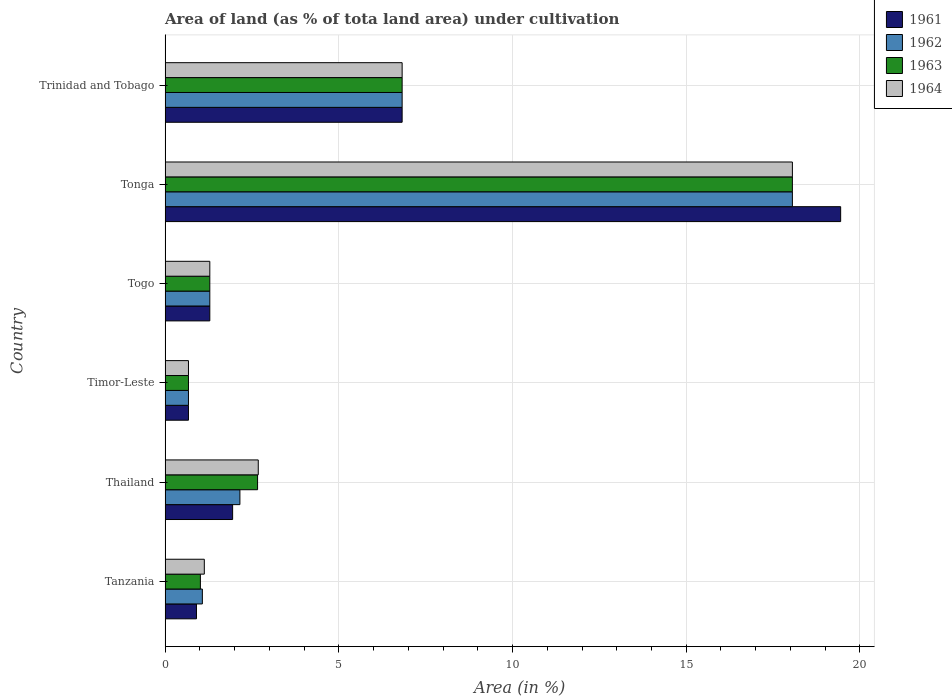How many different coloured bars are there?
Keep it short and to the point. 4. Are the number of bars per tick equal to the number of legend labels?
Ensure brevity in your answer.  Yes. How many bars are there on the 6th tick from the top?
Keep it short and to the point. 4. What is the label of the 3rd group of bars from the top?
Your answer should be very brief. Togo. What is the percentage of land under cultivation in 1961 in Togo?
Offer a terse response. 1.29. Across all countries, what is the maximum percentage of land under cultivation in 1964?
Give a very brief answer. 18.06. Across all countries, what is the minimum percentage of land under cultivation in 1963?
Your response must be concise. 0.67. In which country was the percentage of land under cultivation in 1964 maximum?
Provide a succinct answer. Tonga. In which country was the percentage of land under cultivation in 1964 minimum?
Your answer should be very brief. Timor-Leste. What is the total percentage of land under cultivation in 1961 in the graph?
Ensure brevity in your answer.  31.07. What is the difference between the percentage of land under cultivation in 1961 in Timor-Leste and that in Trinidad and Tobago?
Make the answer very short. -6.15. What is the difference between the percentage of land under cultivation in 1962 in Tanzania and the percentage of land under cultivation in 1961 in Trinidad and Tobago?
Give a very brief answer. -5.75. What is the average percentage of land under cultivation in 1964 per country?
Offer a very short reply. 5.11. What is the difference between the percentage of land under cultivation in 1962 and percentage of land under cultivation in 1963 in Togo?
Ensure brevity in your answer.  0. In how many countries, is the percentage of land under cultivation in 1962 greater than 14 %?
Give a very brief answer. 1. What is the ratio of the percentage of land under cultivation in 1961 in Timor-Leste to that in Trinidad and Tobago?
Your response must be concise. 0.1. Is the percentage of land under cultivation in 1964 in Timor-Leste less than that in Trinidad and Tobago?
Your answer should be very brief. Yes. Is the difference between the percentage of land under cultivation in 1962 in Tonga and Trinidad and Tobago greater than the difference between the percentage of land under cultivation in 1963 in Tonga and Trinidad and Tobago?
Offer a very short reply. No. What is the difference between the highest and the second highest percentage of land under cultivation in 1962?
Your answer should be compact. 11.23. What is the difference between the highest and the lowest percentage of land under cultivation in 1961?
Your answer should be compact. 18.77. In how many countries, is the percentage of land under cultivation in 1961 greater than the average percentage of land under cultivation in 1961 taken over all countries?
Make the answer very short. 2. Is the sum of the percentage of land under cultivation in 1962 in Togo and Tonga greater than the maximum percentage of land under cultivation in 1964 across all countries?
Make the answer very short. Yes. Is it the case that in every country, the sum of the percentage of land under cultivation in 1964 and percentage of land under cultivation in 1962 is greater than the sum of percentage of land under cultivation in 1963 and percentage of land under cultivation in 1961?
Make the answer very short. No. What does the 3rd bar from the top in Tonga represents?
Your answer should be compact. 1962. Is it the case that in every country, the sum of the percentage of land under cultivation in 1961 and percentage of land under cultivation in 1964 is greater than the percentage of land under cultivation in 1963?
Ensure brevity in your answer.  Yes. What is the difference between two consecutive major ticks on the X-axis?
Give a very brief answer. 5. Are the values on the major ticks of X-axis written in scientific E-notation?
Your response must be concise. No. Does the graph contain any zero values?
Keep it short and to the point. No. Does the graph contain grids?
Your response must be concise. Yes. Where does the legend appear in the graph?
Keep it short and to the point. Top right. How are the legend labels stacked?
Provide a short and direct response. Vertical. What is the title of the graph?
Provide a short and direct response. Area of land (as % of tota land area) under cultivation. Does "1976" appear as one of the legend labels in the graph?
Offer a very short reply. No. What is the label or title of the X-axis?
Ensure brevity in your answer.  Area (in %). What is the label or title of the Y-axis?
Your response must be concise. Country. What is the Area (in %) of 1961 in Tanzania?
Ensure brevity in your answer.  0.9. What is the Area (in %) of 1962 in Tanzania?
Ensure brevity in your answer.  1.07. What is the Area (in %) of 1963 in Tanzania?
Ensure brevity in your answer.  1.02. What is the Area (in %) of 1964 in Tanzania?
Make the answer very short. 1.13. What is the Area (in %) in 1961 in Thailand?
Your answer should be compact. 1.94. What is the Area (in %) in 1962 in Thailand?
Ensure brevity in your answer.  2.15. What is the Area (in %) of 1963 in Thailand?
Make the answer very short. 2.66. What is the Area (in %) of 1964 in Thailand?
Ensure brevity in your answer.  2.68. What is the Area (in %) in 1961 in Timor-Leste?
Your answer should be very brief. 0.67. What is the Area (in %) in 1962 in Timor-Leste?
Offer a very short reply. 0.67. What is the Area (in %) in 1963 in Timor-Leste?
Provide a succinct answer. 0.67. What is the Area (in %) of 1964 in Timor-Leste?
Keep it short and to the point. 0.67. What is the Area (in %) in 1961 in Togo?
Your answer should be compact. 1.29. What is the Area (in %) in 1962 in Togo?
Ensure brevity in your answer.  1.29. What is the Area (in %) in 1963 in Togo?
Your response must be concise. 1.29. What is the Area (in %) of 1964 in Togo?
Keep it short and to the point. 1.29. What is the Area (in %) in 1961 in Tonga?
Provide a short and direct response. 19.44. What is the Area (in %) of 1962 in Tonga?
Your answer should be very brief. 18.06. What is the Area (in %) of 1963 in Tonga?
Your response must be concise. 18.06. What is the Area (in %) of 1964 in Tonga?
Your answer should be very brief. 18.06. What is the Area (in %) of 1961 in Trinidad and Tobago?
Give a very brief answer. 6.82. What is the Area (in %) in 1962 in Trinidad and Tobago?
Offer a terse response. 6.82. What is the Area (in %) in 1963 in Trinidad and Tobago?
Provide a succinct answer. 6.82. What is the Area (in %) in 1964 in Trinidad and Tobago?
Your answer should be compact. 6.82. Across all countries, what is the maximum Area (in %) of 1961?
Provide a succinct answer. 19.44. Across all countries, what is the maximum Area (in %) in 1962?
Give a very brief answer. 18.06. Across all countries, what is the maximum Area (in %) of 1963?
Give a very brief answer. 18.06. Across all countries, what is the maximum Area (in %) in 1964?
Keep it short and to the point. 18.06. Across all countries, what is the minimum Area (in %) in 1961?
Keep it short and to the point. 0.67. Across all countries, what is the minimum Area (in %) in 1962?
Provide a short and direct response. 0.67. Across all countries, what is the minimum Area (in %) of 1963?
Your answer should be compact. 0.67. Across all countries, what is the minimum Area (in %) of 1964?
Your answer should be very brief. 0.67. What is the total Area (in %) in 1961 in the graph?
Keep it short and to the point. 31.07. What is the total Area (in %) in 1962 in the graph?
Provide a short and direct response. 30.06. What is the total Area (in %) in 1963 in the graph?
Keep it short and to the point. 30.52. What is the total Area (in %) of 1964 in the graph?
Keep it short and to the point. 30.65. What is the difference between the Area (in %) in 1961 in Tanzania and that in Thailand?
Make the answer very short. -1.04. What is the difference between the Area (in %) in 1962 in Tanzania and that in Thailand?
Offer a very short reply. -1.08. What is the difference between the Area (in %) in 1963 in Tanzania and that in Thailand?
Provide a short and direct response. -1.65. What is the difference between the Area (in %) of 1964 in Tanzania and that in Thailand?
Your answer should be very brief. -1.55. What is the difference between the Area (in %) in 1961 in Tanzania and that in Timor-Leste?
Offer a very short reply. 0.23. What is the difference between the Area (in %) in 1962 in Tanzania and that in Timor-Leste?
Your response must be concise. 0.4. What is the difference between the Area (in %) of 1963 in Tanzania and that in Timor-Leste?
Your answer should be very brief. 0.34. What is the difference between the Area (in %) in 1964 in Tanzania and that in Timor-Leste?
Provide a short and direct response. 0.46. What is the difference between the Area (in %) of 1961 in Tanzania and that in Togo?
Your response must be concise. -0.38. What is the difference between the Area (in %) of 1962 in Tanzania and that in Togo?
Provide a short and direct response. -0.21. What is the difference between the Area (in %) of 1963 in Tanzania and that in Togo?
Your answer should be compact. -0.27. What is the difference between the Area (in %) of 1964 in Tanzania and that in Togo?
Your response must be concise. -0.16. What is the difference between the Area (in %) of 1961 in Tanzania and that in Tonga?
Ensure brevity in your answer.  -18.54. What is the difference between the Area (in %) in 1962 in Tanzania and that in Tonga?
Offer a terse response. -16.98. What is the difference between the Area (in %) of 1963 in Tanzania and that in Tonga?
Offer a terse response. -17.04. What is the difference between the Area (in %) in 1964 in Tanzania and that in Tonga?
Give a very brief answer. -16.93. What is the difference between the Area (in %) of 1961 in Tanzania and that in Trinidad and Tobago?
Your answer should be very brief. -5.92. What is the difference between the Area (in %) in 1962 in Tanzania and that in Trinidad and Tobago?
Your answer should be compact. -5.75. What is the difference between the Area (in %) in 1963 in Tanzania and that in Trinidad and Tobago?
Make the answer very short. -5.81. What is the difference between the Area (in %) in 1964 in Tanzania and that in Trinidad and Tobago?
Make the answer very short. -5.69. What is the difference between the Area (in %) of 1961 in Thailand and that in Timor-Leste?
Give a very brief answer. 1.27. What is the difference between the Area (in %) of 1962 in Thailand and that in Timor-Leste?
Your answer should be compact. 1.48. What is the difference between the Area (in %) of 1963 in Thailand and that in Timor-Leste?
Offer a very short reply. 1.99. What is the difference between the Area (in %) in 1964 in Thailand and that in Timor-Leste?
Provide a short and direct response. 2.01. What is the difference between the Area (in %) of 1961 in Thailand and that in Togo?
Keep it short and to the point. 0.66. What is the difference between the Area (in %) of 1962 in Thailand and that in Togo?
Ensure brevity in your answer.  0.87. What is the difference between the Area (in %) in 1963 in Thailand and that in Togo?
Offer a terse response. 1.38. What is the difference between the Area (in %) in 1964 in Thailand and that in Togo?
Offer a terse response. 1.39. What is the difference between the Area (in %) in 1961 in Thailand and that in Tonga?
Provide a short and direct response. -17.5. What is the difference between the Area (in %) in 1962 in Thailand and that in Tonga?
Offer a terse response. -15.9. What is the difference between the Area (in %) of 1963 in Thailand and that in Tonga?
Your answer should be very brief. -15.39. What is the difference between the Area (in %) in 1964 in Thailand and that in Tonga?
Make the answer very short. -15.37. What is the difference between the Area (in %) of 1961 in Thailand and that in Trinidad and Tobago?
Your answer should be compact. -4.88. What is the difference between the Area (in %) of 1962 in Thailand and that in Trinidad and Tobago?
Offer a very short reply. -4.67. What is the difference between the Area (in %) of 1963 in Thailand and that in Trinidad and Tobago?
Keep it short and to the point. -4.16. What is the difference between the Area (in %) of 1964 in Thailand and that in Trinidad and Tobago?
Your response must be concise. -4.14. What is the difference between the Area (in %) in 1961 in Timor-Leste and that in Togo?
Your answer should be very brief. -0.61. What is the difference between the Area (in %) in 1962 in Timor-Leste and that in Togo?
Provide a succinct answer. -0.61. What is the difference between the Area (in %) of 1963 in Timor-Leste and that in Togo?
Offer a very short reply. -0.61. What is the difference between the Area (in %) of 1964 in Timor-Leste and that in Togo?
Make the answer very short. -0.61. What is the difference between the Area (in %) in 1961 in Timor-Leste and that in Tonga?
Make the answer very short. -18.77. What is the difference between the Area (in %) of 1962 in Timor-Leste and that in Tonga?
Offer a very short reply. -17.38. What is the difference between the Area (in %) in 1963 in Timor-Leste and that in Tonga?
Provide a short and direct response. -17.38. What is the difference between the Area (in %) in 1964 in Timor-Leste and that in Tonga?
Make the answer very short. -17.38. What is the difference between the Area (in %) in 1961 in Timor-Leste and that in Trinidad and Tobago?
Provide a succinct answer. -6.15. What is the difference between the Area (in %) of 1962 in Timor-Leste and that in Trinidad and Tobago?
Make the answer very short. -6.15. What is the difference between the Area (in %) of 1963 in Timor-Leste and that in Trinidad and Tobago?
Your answer should be compact. -6.15. What is the difference between the Area (in %) of 1964 in Timor-Leste and that in Trinidad and Tobago?
Your response must be concise. -6.15. What is the difference between the Area (in %) of 1961 in Togo and that in Tonga?
Ensure brevity in your answer.  -18.16. What is the difference between the Area (in %) in 1962 in Togo and that in Tonga?
Your answer should be very brief. -16.77. What is the difference between the Area (in %) in 1963 in Togo and that in Tonga?
Keep it short and to the point. -16.77. What is the difference between the Area (in %) of 1964 in Togo and that in Tonga?
Provide a short and direct response. -16.77. What is the difference between the Area (in %) in 1961 in Togo and that in Trinidad and Tobago?
Ensure brevity in your answer.  -5.54. What is the difference between the Area (in %) in 1962 in Togo and that in Trinidad and Tobago?
Your answer should be very brief. -5.54. What is the difference between the Area (in %) in 1963 in Togo and that in Trinidad and Tobago?
Give a very brief answer. -5.54. What is the difference between the Area (in %) in 1964 in Togo and that in Trinidad and Tobago?
Your answer should be very brief. -5.54. What is the difference between the Area (in %) of 1961 in Tonga and that in Trinidad and Tobago?
Make the answer very short. 12.62. What is the difference between the Area (in %) of 1962 in Tonga and that in Trinidad and Tobago?
Give a very brief answer. 11.23. What is the difference between the Area (in %) in 1963 in Tonga and that in Trinidad and Tobago?
Ensure brevity in your answer.  11.23. What is the difference between the Area (in %) in 1964 in Tonga and that in Trinidad and Tobago?
Your answer should be compact. 11.23. What is the difference between the Area (in %) of 1961 in Tanzania and the Area (in %) of 1962 in Thailand?
Your response must be concise. -1.25. What is the difference between the Area (in %) of 1961 in Tanzania and the Area (in %) of 1963 in Thailand?
Offer a terse response. -1.76. What is the difference between the Area (in %) in 1961 in Tanzania and the Area (in %) in 1964 in Thailand?
Offer a very short reply. -1.78. What is the difference between the Area (in %) in 1962 in Tanzania and the Area (in %) in 1963 in Thailand?
Offer a very short reply. -1.59. What is the difference between the Area (in %) of 1962 in Tanzania and the Area (in %) of 1964 in Thailand?
Make the answer very short. -1.61. What is the difference between the Area (in %) of 1963 in Tanzania and the Area (in %) of 1964 in Thailand?
Provide a short and direct response. -1.67. What is the difference between the Area (in %) of 1961 in Tanzania and the Area (in %) of 1962 in Timor-Leste?
Offer a very short reply. 0.23. What is the difference between the Area (in %) in 1961 in Tanzania and the Area (in %) in 1963 in Timor-Leste?
Your answer should be compact. 0.23. What is the difference between the Area (in %) in 1961 in Tanzania and the Area (in %) in 1964 in Timor-Leste?
Provide a succinct answer. 0.23. What is the difference between the Area (in %) of 1962 in Tanzania and the Area (in %) of 1963 in Timor-Leste?
Offer a terse response. 0.4. What is the difference between the Area (in %) of 1962 in Tanzania and the Area (in %) of 1964 in Timor-Leste?
Offer a very short reply. 0.4. What is the difference between the Area (in %) of 1963 in Tanzania and the Area (in %) of 1964 in Timor-Leste?
Offer a terse response. 0.34. What is the difference between the Area (in %) of 1961 in Tanzania and the Area (in %) of 1962 in Togo?
Make the answer very short. -0.38. What is the difference between the Area (in %) in 1961 in Tanzania and the Area (in %) in 1963 in Togo?
Provide a succinct answer. -0.38. What is the difference between the Area (in %) of 1961 in Tanzania and the Area (in %) of 1964 in Togo?
Your answer should be compact. -0.38. What is the difference between the Area (in %) of 1962 in Tanzania and the Area (in %) of 1963 in Togo?
Your answer should be compact. -0.21. What is the difference between the Area (in %) of 1962 in Tanzania and the Area (in %) of 1964 in Togo?
Make the answer very short. -0.21. What is the difference between the Area (in %) of 1963 in Tanzania and the Area (in %) of 1964 in Togo?
Offer a very short reply. -0.27. What is the difference between the Area (in %) of 1961 in Tanzania and the Area (in %) of 1962 in Tonga?
Offer a terse response. -17.15. What is the difference between the Area (in %) of 1961 in Tanzania and the Area (in %) of 1963 in Tonga?
Provide a short and direct response. -17.15. What is the difference between the Area (in %) of 1961 in Tanzania and the Area (in %) of 1964 in Tonga?
Your response must be concise. -17.15. What is the difference between the Area (in %) in 1962 in Tanzania and the Area (in %) in 1963 in Tonga?
Provide a succinct answer. -16.98. What is the difference between the Area (in %) of 1962 in Tanzania and the Area (in %) of 1964 in Tonga?
Your response must be concise. -16.98. What is the difference between the Area (in %) in 1963 in Tanzania and the Area (in %) in 1964 in Tonga?
Make the answer very short. -17.04. What is the difference between the Area (in %) of 1961 in Tanzania and the Area (in %) of 1962 in Trinidad and Tobago?
Your response must be concise. -5.92. What is the difference between the Area (in %) of 1961 in Tanzania and the Area (in %) of 1963 in Trinidad and Tobago?
Ensure brevity in your answer.  -5.92. What is the difference between the Area (in %) in 1961 in Tanzania and the Area (in %) in 1964 in Trinidad and Tobago?
Your response must be concise. -5.92. What is the difference between the Area (in %) of 1962 in Tanzania and the Area (in %) of 1963 in Trinidad and Tobago?
Ensure brevity in your answer.  -5.75. What is the difference between the Area (in %) in 1962 in Tanzania and the Area (in %) in 1964 in Trinidad and Tobago?
Ensure brevity in your answer.  -5.75. What is the difference between the Area (in %) of 1963 in Tanzania and the Area (in %) of 1964 in Trinidad and Tobago?
Ensure brevity in your answer.  -5.81. What is the difference between the Area (in %) in 1961 in Thailand and the Area (in %) in 1962 in Timor-Leste?
Ensure brevity in your answer.  1.27. What is the difference between the Area (in %) in 1961 in Thailand and the Area (in %) in 1963 in Timor-Leste?
Your response must be concise. 1.27. What is the difference between the Area (in %) of 1961 in Thailand and the Area (in %) of 1964 in Timor-Leste?
Offer a terse response. 1.27. What is the difference between the Area (in %) of 1962 in Thailand and the Area (in %) of 1963 in Timor-Leste?
Your answer should be very brief. 1.48. What is the difference between the Area (in %) in 1962 in Thailand and the Area (in %) in 1964 in Timor-Leste?
Offer a very short reply. 1.48. What is the difference between the Area (in %) in 1963 in Thailand and the Area (in %) in 1964 in Timor-Leste?
Your answer should be compact. 1.99. What is the difference between the Area (in %) in 1961 in Thailand and the Area (in %) in 1962 in Togo?
Offer a very short reply. 0.66. What is the difference between the Area (in %) of 1961 in Thailand and the Area (in %) of 1963 in Togo?
Offer a very short reply. 0.66. What is the difference between the Area (in %) of 1961 in Thailand and the Area (in %) of 1964 in Togo?
Your answer should be compact. 0.66. What is the difference between the Area (in %) in 1962 in Thailand and the Area (in %) in 1963 in Togo?
Give a very brief answer. 0.87. What is the difference between the Area (in %) in 1962 in Thailand and the Area (in %) in 1964 in Togo?
Your response must be concise. 0.87. What is the difference between the Area (in %) in 1963 in Thailand and the Area (in %) in 1964 in Togo?
Your answer should be compact. 1.38. What is the difference between the Area (in %) in 1961 in Thailand and the Area (in %) in 1962 in Tonga?
Offer a terse response. -16.11. What is the difference between the Area (in %) in 1961 in Thailand and the Area (in %) in 1963 in Tonga?
Your answer should be compact. -16.11. What is the difference between the Area (in %) of 1961 in Thailand and the Area (in %) of 1964 in Tonga?
Offer a very short reply. -16.11. What is the difference between the Area (in %) in 1962 in Thailand and the Area (in %) in 1963 in Tonga?
Keep it short and to the point. -15.9. What is the difference between the Area (in %) of 1962 in Thailand and the Area (in %) of 1964 in Tonga?
Provide a short and direct response. -15.9. What is the difference between the Area (in %) in 1963 in Thailand and the Area (in %) in 1964 in Tonga?
Your response must be concise. -15.39. What is the difference between the Area (in %) in 1961 in Thailand and the Area (in %) in 1962 in Trinidad and Tobago?
Keep it short and to the point. -4.88. What is the difference between the Area (in %) in 1961 in Thailand and the Area (in %) in 1963 in Trinidad and Tobago?
Make the answer very short. -4.88. What is the difference between the Area (in %) in 1961 in Thailand and the Area (in %) in 1964 in Trinidad and Tobago?
Keep it short and to the point. -4.88. What is the difference between the Area (in %) of 1962 in Thailand and the Area (in %) of 1963 in Trinidad and Tobago?
Your response must be concise. -4.67. What is the difference between the Area (in %) in 1962 in Thailand and the Area (in %) in 1964 in Trinidad and Tobago?
Make the answer very short. -4.67. What is the difference between the Area (in %) of 1963 in Thailand and the Area (in %) of 1964 in Trinidad and Tobago?
Your response must be concise. -4.16. What is the difference between the Area (in %) of 1961 in Timor-Leste and the Area (in %) of 1962 in Togo?
Give a very brief answer. -0.61. What is the difference between the Area (in %) of 1961 in Timor-Leste and the Area (in %) of 1963 in Togo?
Provide a succinct answer. -0.61. What is the difference between the Area (in %) of 1961 in Timor-Leste and the Area (in %) of 1964 in Togo?
Your answer should be very brief. -0.61. What is the difference between the Area (in %) in 1962 in Timor-Leste and the Area (in %) in 1963 in Togo?
Provide a short and direct response. -0.61. What is the difference between the Area (in %) of 1962 in Timor-Leste and the Area (in %) of 1964 in Togo?
Your response must be concise. -0.61. What is the difference between the Area (in %) in 1963 in Timor-Leste and the Area (in %) in 1964 in Togo?
Offer a very short reply. -0.61. What is the difference between the Area (in %) of 1961 in Timor-Leste and the Area (in %) of 1962 in Tonga?
Ensure brevity in your answer.  -17.38. What is the difference between the Area (in %) in 1961 in Timor-Leste and the Area (in %) in 1963 in Tonga?
Make the answer very short. -17.38. What is the difference between the Area (in %) in 1961 in Timor-Leste and the Area (in %) in 1964 in Tonga?
Provide a short and direct response. -17.38. What is the difference between the Area (in %) in 1962 in Timor-Leste and the Area (in %) in 1963 in Tonga?
Offer a terse response. -17.38. What is the difference between the Area (in %) in 1962 in Timor-Leste and the Area (in %) in 1964 in Tonga?
Offer a very short reply. -17.38. What is the difference between the Area (in %) in 1963 in Timor-Leste and the Area (in %) in 1964 in Tonga?
Provide a short and direct response. -17.38. What is the difference between the Area (in %) in 1961 in Timor-Leste and the Area (in %) in 1962 in Trinidad and Tobago?
Provide a succinct answer. -6.15. What is the difference between the Area (in %) of 1961 in Timor-Leste and the Area (in %) of 1963 in Trinidad and Tobago?
Provide a short and direct response. -6.15. What is the difference between the Area (in %) in 1961 in Timor-Leste and the Area (in %) in 1964 in Trinidad and Tobago?
Give a very brief answer. -6.15. What is the difference between the Area (in %) of 1962 in Timor-Leste and the Area (in %) of 1963 in Trinidad and Tobago?
Offer a terse response. -6.15. What is the difference between the Area (in %) of 1962 in Timor-Leste and the Area (in %) of 1964 in Trinidad and Tobago?
Provide a short and direct response. -6.15. What is the difference between the Area (in %) in 1963 in Timor-Leste and the Area (in %) in 1964 in Trinidad and Tobago?
Provide a short and direct response. -6.15. What is the difference between the Area (in %) in 1961 in Togo and the Area (in %) in 1962 in Tonga?
Your answer should be compact. -16.77. What is the difference between the Area (in %) in 1961 in Togo and the Area (in %) in 1963 in Tonga?
Your answer should be very brief. -16.77. What is the difference between the Area (in %) in 1961 in Togo and the Area (in %) in 1964 in Tonga?
Your answer should be compact. -16.77. What is the difference between the Area (in %) in 1962 in Togo and the Area (in %) in 1963 in Tonga?
Ensure brevity in your answer.  -16.77. What is the difference between the Area (in %) of 1962 in Togo and the Area (in %) of 1964 in Tonga?
Offer a terse response. -16.77. What is the difference between the Area (in %) of 1963 in Togo and the Area (in %) of 1964 in Tonga?
Ensure brevity in your answer.  -16.77. What is the difference between the Area (in %) of 1961 in Togo and the Area (in %) of 1962 in Trinidad and Tobago?
Give a very brief answer. -5.54. What is the difference between the Area (in %) in 1961 in Togo and the Area (in %) in 1963 in Trinidad and Tobago?
Offer a very short reply. -5.54. What is the difference between the Area (in %) in 1961 in Togo and the Area (in %) in 1964 in Trinidad and Tobago?
Provide a short and direct response. -5.54. What is the difference between the Area (in %) in 1962 in Togo and the Area (in %) in 1963 in Trinidad and Tobago?
Ensure brevity in your answer.  -5.54. What is the difference between the Area (in %) of 1962 in Togo and the Area (in %) of 1964 in Trinidad and Tobago?
Provide a short and direct response. -5.54. What is the difference between the Area (in %) of 1963 in Togo and the Area (in %) of 1964 in Trinidad and Tobago?
Offer a terse response. -5.54. What is the difference between the Area (in %) of 1961 in Tonga and the Area (in %) of 1962 in Trinidad and Tobago?
Your answer should be very brief. 12.62. What is the difference between the Area (in %) in 1961 in Tonga and the Area (in %) in 1963 in Trinidad and Tobago?
Your answer should be compact. 12.62. What is the difference between the Area (in %) in 1961 in Tonga and the Area (in %) in 1964 in Trinidad and Tobago?
Your response must be concise. 12.62. What is the difference between the Area (in %) in 1962 in Tonga and the Area (in %) in 1963 in Trinidad and Tobago?
Your answer should be compact. 11.23. What is the difference between the Area (in %) in 1962 in Tonga and the Area (in %) in 1964 in Trinidad and Tobago?
Offer a very short reply. 11.23. What is the difference between the Area (in %) in 1963 in Tonga and the Area (in %) in 1964 in Trinidad and Tobago?
Your answer should be compact. 11.23. What is the average Area (in %) of 1961 per country?
Give a very brief answer. 5.18. What is the average Area (in %) of 1962 per country?
Your response must be concise. 5.01. What is the average Area (in %) in 1963 per country?
Keep it short and to the point. 5.09. What is the average Area (in %) of 1964 per country?
Offer a very short reply. 5.11. What is the difference between the Area (in %) of 1961 and Area (in %) of 1962 in Tanzania?
Keep it short and to the point. -0.17. What is the difference between the Area (in %) in 1961 and Area (in %) in 1963 in Tanzania?
Keep it short and to the point. -0.11. What is the difference between the Area (in %) in 1961 and Area (in %) in 1964 in Tanzania?
Provide a short and direct response. -0.23. What is the difference between the Area (in %) in 1962 and Area (in %) in 1963 in Tanzania?
Offer a very short reply. 0.06. What is the difference between the Area (in %) of 1962 and Area (in %) of 1964 in Tanzania?
Make the answer very short. -0.06. What is the difference between the Area (in %) in 1963 and Area (in %) in 1964 in Tanzania?
Offer a terse response. -0.11. What is the difference between the Area (in %) in 1961 and Area (in %) in 1962 in Thailand?
Your answer should be very brief. -0.21. What is the difference between the Area (in %) of 1961 and Area (in %) of 1963 in Thailand?
Your answer should be compact. -0.72. What is the difference between the Area (in %) of 1961 and Area (in %) of 1964 in Thailand?
Provide a succinct answer. -0.74. What is the difference between the Area (in %) of 1962 and Area (in %) of 1963 in Thailand?
Your response must be concise. -0.51. What is the difference between the Area (in %) of 1962 and Area (in %) of 1964 in Thailand?
Your response must be concise. -0.53. What is the difference between the Area (in %) of 1963 and Area (in %) of 1964 in Thailand?
Keep it short and to the point. -0.02. What is the difference between the Area (in %) of 1961 and Area (in %) of 1962 in Timor-Leste?
Offer a terse response. 0. What is the difference between the Area (in %) in 1962 and Area (in %) in 1963 in Timor-Leste?
Provide a short and direct response. 0. What is the difference between the Area (in %) of 1962 and Area (in %) of 1964 in Timor-Leste?
Provide a short and direct response. 0. What is the difference between the Area (in %) of 1961 and Area (in %) of 1962 in Togo?
Your answer should be very brief. 0. What is the difference between the Area (in %) in 1961 and Area (in %) in 1964 in Togo?
Give a very brief answer. 0. What is the difference between the Area (in %) of 1961 and Area (in %) of 1962 in Tonga?
Make the answer very short. 1.39. What is the difference between the Area (in %) of 1961 and Area (in %) of 1963 in Tonga?
Offer a very short reply. 1.39. What is the difference between the Area (in %) in 1961 and Area (in %) in 1964 in Tonga?
Your answer should be compact. 1.39. What is the difference between the Area (in %) in 1962 and Area (in %) in 1964 in Tonga?
Your response must be concise. 0. What is the difference between the Area (in %) of 1963 and Area (in %) of 1964 in Tonga?
Give a very brief answer. 0. What is the difference between the Area (in %) in 1961 and Area (in %) in 1962 in Trinidad and Tobago?
Make the answer very short. 0. What is the difference between the Area (in %) of 1962 and Area (in %) of 1963 in Trinidad and Tobago?
Give a very brief answer. 0. What is the ratio of the Area (in %) of 1961 in Tanzania to that in Thailand?
Give a very brief answer. 0.46. What is the ratio of the Area (in %) of 1962 in Tanzania to that in Thailand?
Offer a terse response. 0.5. What is the ratio of the Area (in %) in 1963 in Tanzania to that in Thailand?
Provide a succinct answer. 0.38. What is the ratio of the Area (in %) in 1964 in Tanzania to that in Thailand?
Offer a terse response. 0.42. What is the ratio of the Area (in %) of 1961 in Tanzania to that in Timor-Leste?
Keep it short and to the point. 1.34. What is the ratio of the Area (in %) of 1962 in Tanzania to that in Timor-Leste?
Give a very brief answer. 1.59. What is the ratio of the Area (in %) of 1963 in Tanzania to that in Timor-Leste?
Your response must be concise. 1.51. What is the ratio of the Area (in %) of 1964 in Tanzania to that in Timor-Leste?
Offer a terse response. 1.68. What is the ratio of the Area (in %) of 1961 in Tanzania to that in Togo?
Your answer should be compact. 0.7. What is the ratio of the Area (in %) in 1963 in Tanzania to that in Togo?
Make the answer very short. 0.79. What is the ratio of the Area (in %) in 1964 in Tanzania to that in Togo?
Provide a short and direct response. 0.88. What is the ratio of the Area (in %) in 1961 in Tanzania to that in Tonga?
Provide a succinct answer. 0.05. What is the ratio of the Area (in %) of 1962 in Tanzania to that in Tonga?
Keep it short and to the point. 0.06. What is the ratio of the Area (in %) in 1963 in Tanzania to that in Tonga?
Make the answer very short. 0.06. What is the ratio of the Area (in %) in 1964 in Tanzania to that in Tonga?
Make the answer very short. 0.06. What is the ratio of the Area (in %) in 1961 in Tanzania to that in Trinidad and Tobago?
Your response must be concise. 0.13. What is the ratio of the Area (in %) of 1962 in Tanzania to that in Trinidad and Tobago?
Make the answer very short. 0.16. What is the ratio of the Area (in %) in 1963 in Tanzania to that in Trinidad and Tobago?
Offer a very short reply. 0.15. What is the ratio of the Area (in %) of 1964 in Tanzania to that in Trinidad and Tobago?
Make the answer very short. 0.17. What is the ratio of the Area (in %) in 1961 in Thailand to that in Timor-Leste?
Your answer should be very brief. 2.89. What is the ratio of the Area (in %) in 1962 in Thailand to that in Timor-Leste?
Give a very brief answer. 3.2. What is the ratio of the Area (in %) in 1963 in Thailand to that in Timor-Leste?
Make the answer very short. 3.96. What is the ratio of the Area (in %) in 1964 in Thailand to that in Timor-Leste?
Your answer should be compact. 3.99. What is the ratio of the Area (in %) of 1961 in Thailand to that in Togo?
Offer a terse response. 1.51. What is the ratio of the Area (in %) in 1962 in Thailand to that in Togo?
Your answer should be compact. 1.67. What is the ratio of the Area (in %) of 1963 in Thailand to that in Togo?
Your answer should be compact. 2.07. What is the ratio of the Area (in %) of 1964 in Thailand to that in Togo?
Keep it short and to the point. 2.08. What is the ratio of the Area (in %) in 1961 in Thailand to that in Tonga?
Provide a short and direct response. 0.1. What is the ratio of the Area (in %) of 1962 in Thailand to that in Tonga?
Make the answer very short. 0.12. What is the ratio of the Area (in %) in 1963 in Thailand to that in Tonga?
Provide a succinct answer. 0.15. What is the ratio of the Area (in %) in 1964 in Thailand to that in Tonga?
Give a very brief answer. 0.15. What is the ratio of the Area (in %) in 1961 in Thailand to that in Trinidad and Tobago?
Offer a very short reply. 0.28. What is the ratio of the Area (in %) in 1962 in Thailand to that in Trinidad and Tobago?
Give a very brief answer. 0.32. What is the ratio of the Area (in %) of 1963 in Thailand to that in Trinidad and Tobago?
Your answer should be very brief. 0.39. What is the ratio of the Area (in %) in 1964 in Thailand to that in Trinidad and Tobago?
Give a very brief answer. 0.39. What is the ratio of the Area (in %) in 1961 in Timor-Leste to that in Togo?
Provide a short and direct response. 0.52. What is the ratio of the Area (in %) in 1962 in Timor-Leste to that in Togo?
Your answer should be very brief. 0.52. What is the ratio of the Area (in %) of 1963 in Timor-Leste to that in Togo?
Make the answer very short. 0.52. What is the ratio of the Area (in %) of 1964 in Timor-Leste to that in Togo?
Provide a succinct answer. 0.52. What is the ratio of the Area (in %) in 1961 in Timor-Leste to that in Tonga?
Make the answer very short. 0.03. What is the ratio of the Area (in %) in 1962 in Timor-Leste to that in Tonga?
Keep it short and to the point. 0.04. What is the ratio of the Area (in %) of 1963 in Timor-Leste to that in Tonga?
Offer a very short reply. 0.04. What is the ratio of the Area (in %) of 1964 in Timor-Leste to that in Tonga?
Make the answer very short. 0.04. What is the ratio of the Area (in %) in 1961 in Timor-Leste to that in Trinidad and Tobago?
Offer a very short reply. 0.1. What is the ratio of the Area (in %) in 1962 in Timor-Leste to that in Trinidad and Tobago?
Offer a very short reply. 0.1. What is the ratio of the Area (in %) of 1963 in Timor-Leste to that in Trinidad and Tobago?
Keep it short and to the point. 0.1. What is the ratio of the Area (in %) of 1964 in Timor-Leste to that in Trinidad and Tobago?
Provide a short and direct response. 0.1. What is the ratio of the Area (in %) in 1961 in Togo to that in Tonga?
Offer a terse response. 0.07. What is the ratio of the Area (in %) of 1962 in Togo to that in Tonga?
Provide a short and direct response. 0.07. What is the ratio of the Area (in %) in 1963 in Togo to that in Tonga?
Provide a short and direct response. 0.07. What is the ratio of the Area (in %) in 1964 in Togo to that in Tonga?
Provide a succinct answer. 0.07. What is the ratio of the Area (in %) of 1961 in Togo to that in Trinidad and Tobago?
Your response must be concise. 0.19. What is the ratio of the Area (in %) in 1962 in Togo to that in Trinidad and Tobago?
Your response must be concise. 0.19. What is the ratio of the Area (in %) of 1963 in Togo to that in Trinidad and Tobago?
Keep it short and to the point. 0.19. What is the ratio of the Area (in %) of 1964 in Togo to that in Trinidad and Tobago?
Make the answer very short. 0.19. What is the ratio of the Area (in %) in 1961 in Tonga to that in Trinidad and Tobago?
Make the answer very short. 2.85. What is the ratio of the Area (in %) of 1962 in Tonga to that in Trinidad and Tobago?
Provide a short and direct response. 2.65. What is the ratio of the Area (in %) in 1963 in Tonga to that in Trinidad and Tobago?
Ensure brevity in your answer.  2.65. What is the ratio of the Area (in %) of 1964 in Tonga to that in Trinidad and Tobago?
Give a very brief answer. 2.65. What is the difference between the highest and the second highest Area (in %) in 1961?
Your answer should be very brief. 12.62. What is the difference between the highest and the second highest Area (in %) of 1962?
Your answer should be very brief. 11.23. What is the difference between the highest and the second highest Area (in %) of 1963?
Ensure brevity in your answer.  11.23. What is the difference between the highest and the second highest Area (in %) of 1964?
Provide a short and direct response. 11.23. What is the difference between the highest and the lowest Area (in %) of 1961?
Your answer should be very brief. 18.77. What is the difference between the highest and the lowest Area (in %) of 1962?
Make the answer very short. 17.38. What is the difference between the highest and the lowest Area (in %) of 1963?
Your answer should be very brief. 17.38. What is the difference between the highest and the lowest Area (in %) of 1964?
Offer a terse response. 17.38. 